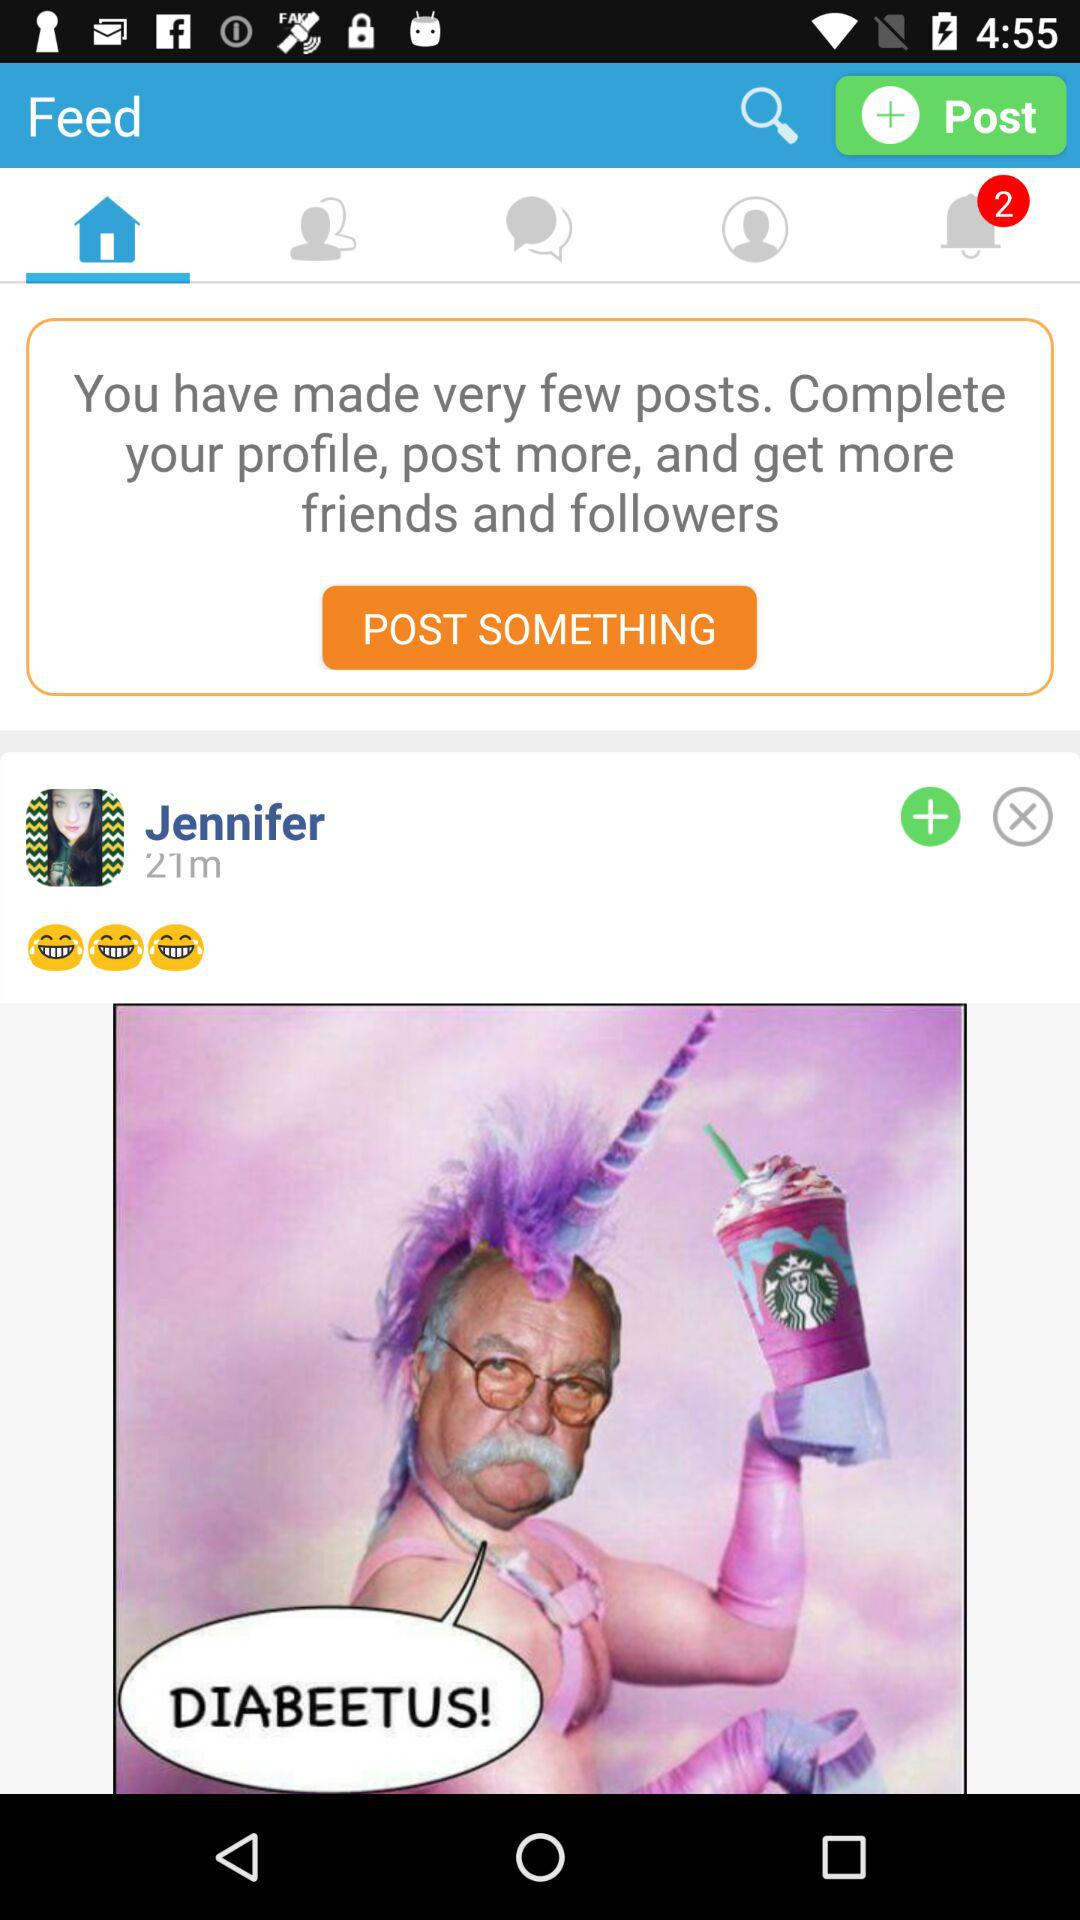How many unread notifications are there? There are 2 unread notifications. 